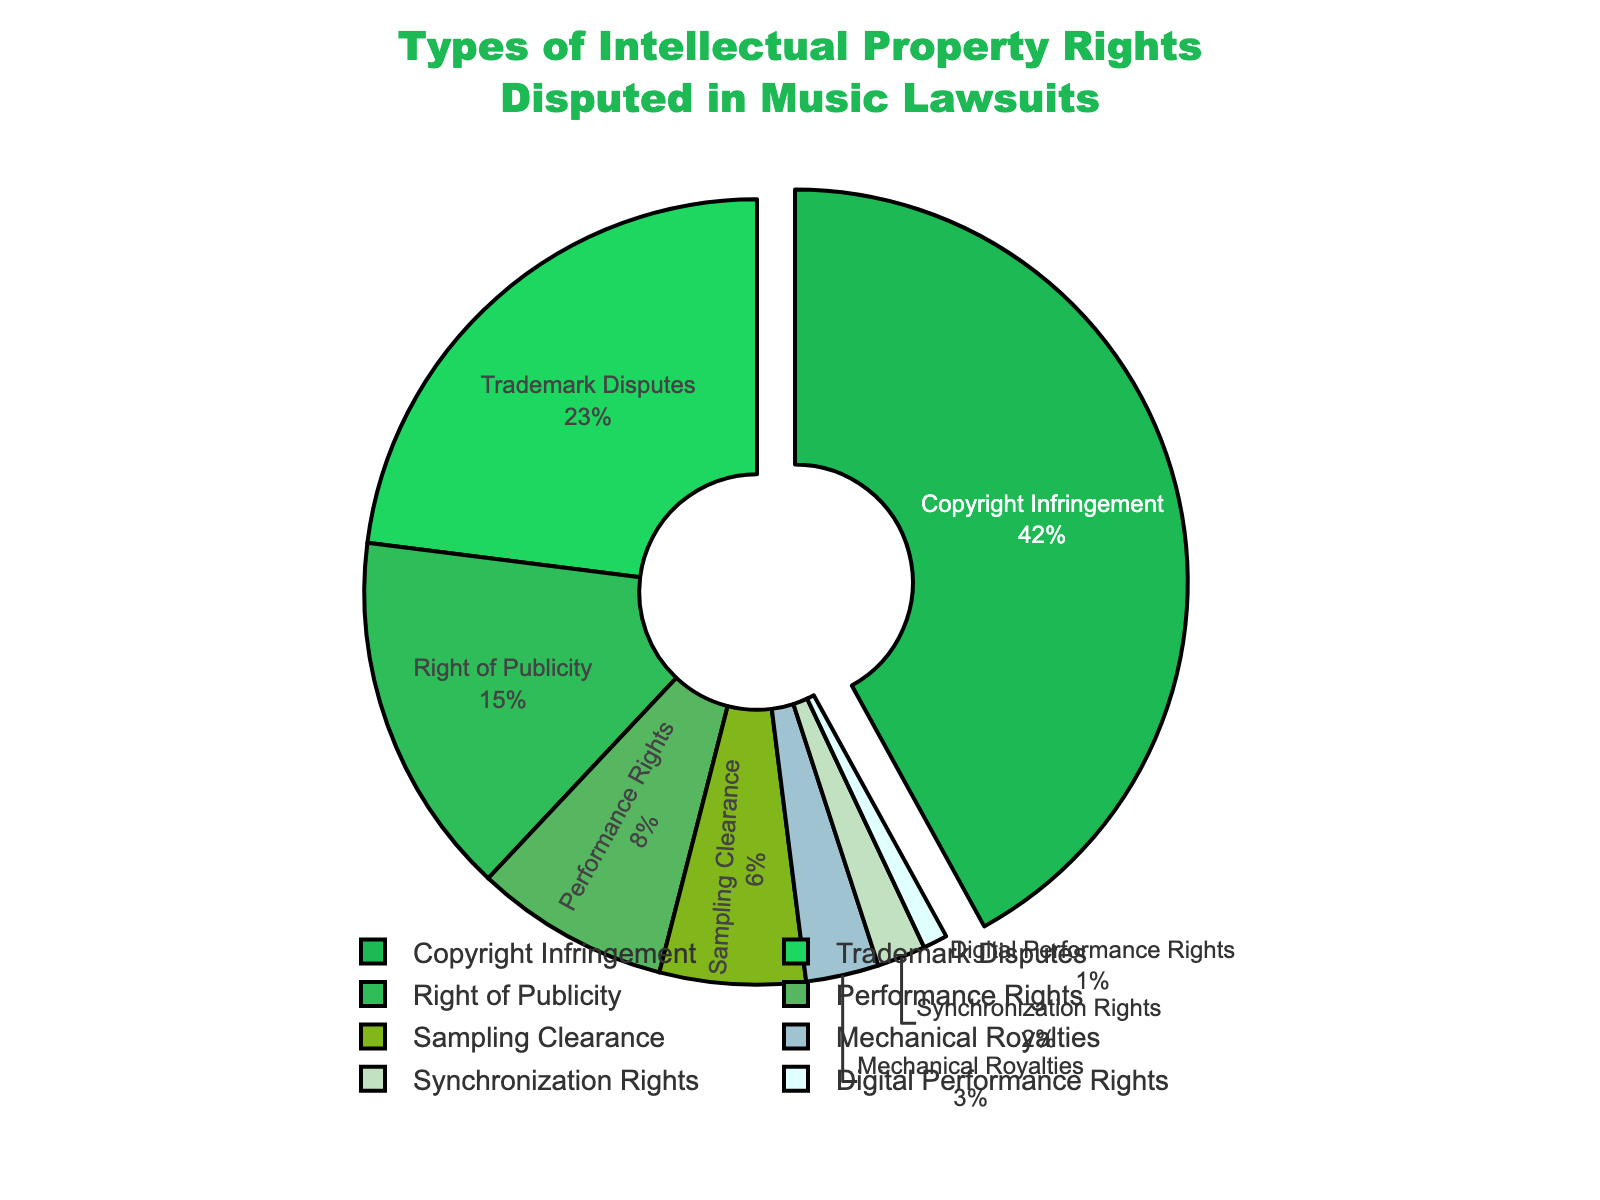Which type of intellectual property right is disputed the most in music lawsuits? The largest section of the pie chart is labeled "Copyright Infringement," indicating it is the most frequently disputed.
Answer: Copyright Infringement What percentage of music lawsuits involve performance rights disputes? The section labeled "Performance Rights" provides this information. It occupies 8% of the pie chart.
Answer: 8% How does the frequency of trademark disputes compare to the right of publicity disputes? Compare the two sections labeled "Trademark Disputes" and "Right of Publicity." Trademark disputes account for 23% while right of publicity disputes account for 15%. 23% is greater than 15%.
Answer: Trademark disputes are more frequent What proportion of disputes involve either mechanical royalties or synchronization rights? Add the percentages for Mechanical Royalties (3%) and Synchronization Rights (2%). 3% + 2% = 5%.
Answer: 5% What fraction of the pie chart is dedicated to sampling clearance disputes? The section labeled "Sampling Clearance" provides this data. It indicates a percentage of 6%, which is 6/100 or 0.06 as a fraction.
Answer: 0.06 Between digital performance rights and synchronization rights, which is less frequently disputed? Compare the two sections labeled "Synchronization Rights" (2%) and "Digital Performance Rights" (1%). 1% is less than 2%.
Answer: Digital Performance Rights What are the total percentages for the top three most frequently disputed intellectual property rights in music lawsuits? Sum the percentages for Copyright Infringement (42%), Trademark Disputes (23%), and Right of Publicity (15%). 42% + 23% + 15% = 80%.
Answer: 80% How much larger is the percentage of copyright infringement disputes compared to performance rights disputes? Subtract the percentage for Performance Rights (8%) from the percentage for Copyright Infringement (42%). 42% - 8% = 34%.
Answer: 34% If you combine disputes involving sampling clearance and mechanical royalties, do they exceed right of publicity disputes? Add the percentages for Sampling Clearance (6%) and Mechanical Royalties (3%), then compare this sum to Right of Publicity (15%). 6% + 3% = 9%, which is less than 15%.
Answer: No 